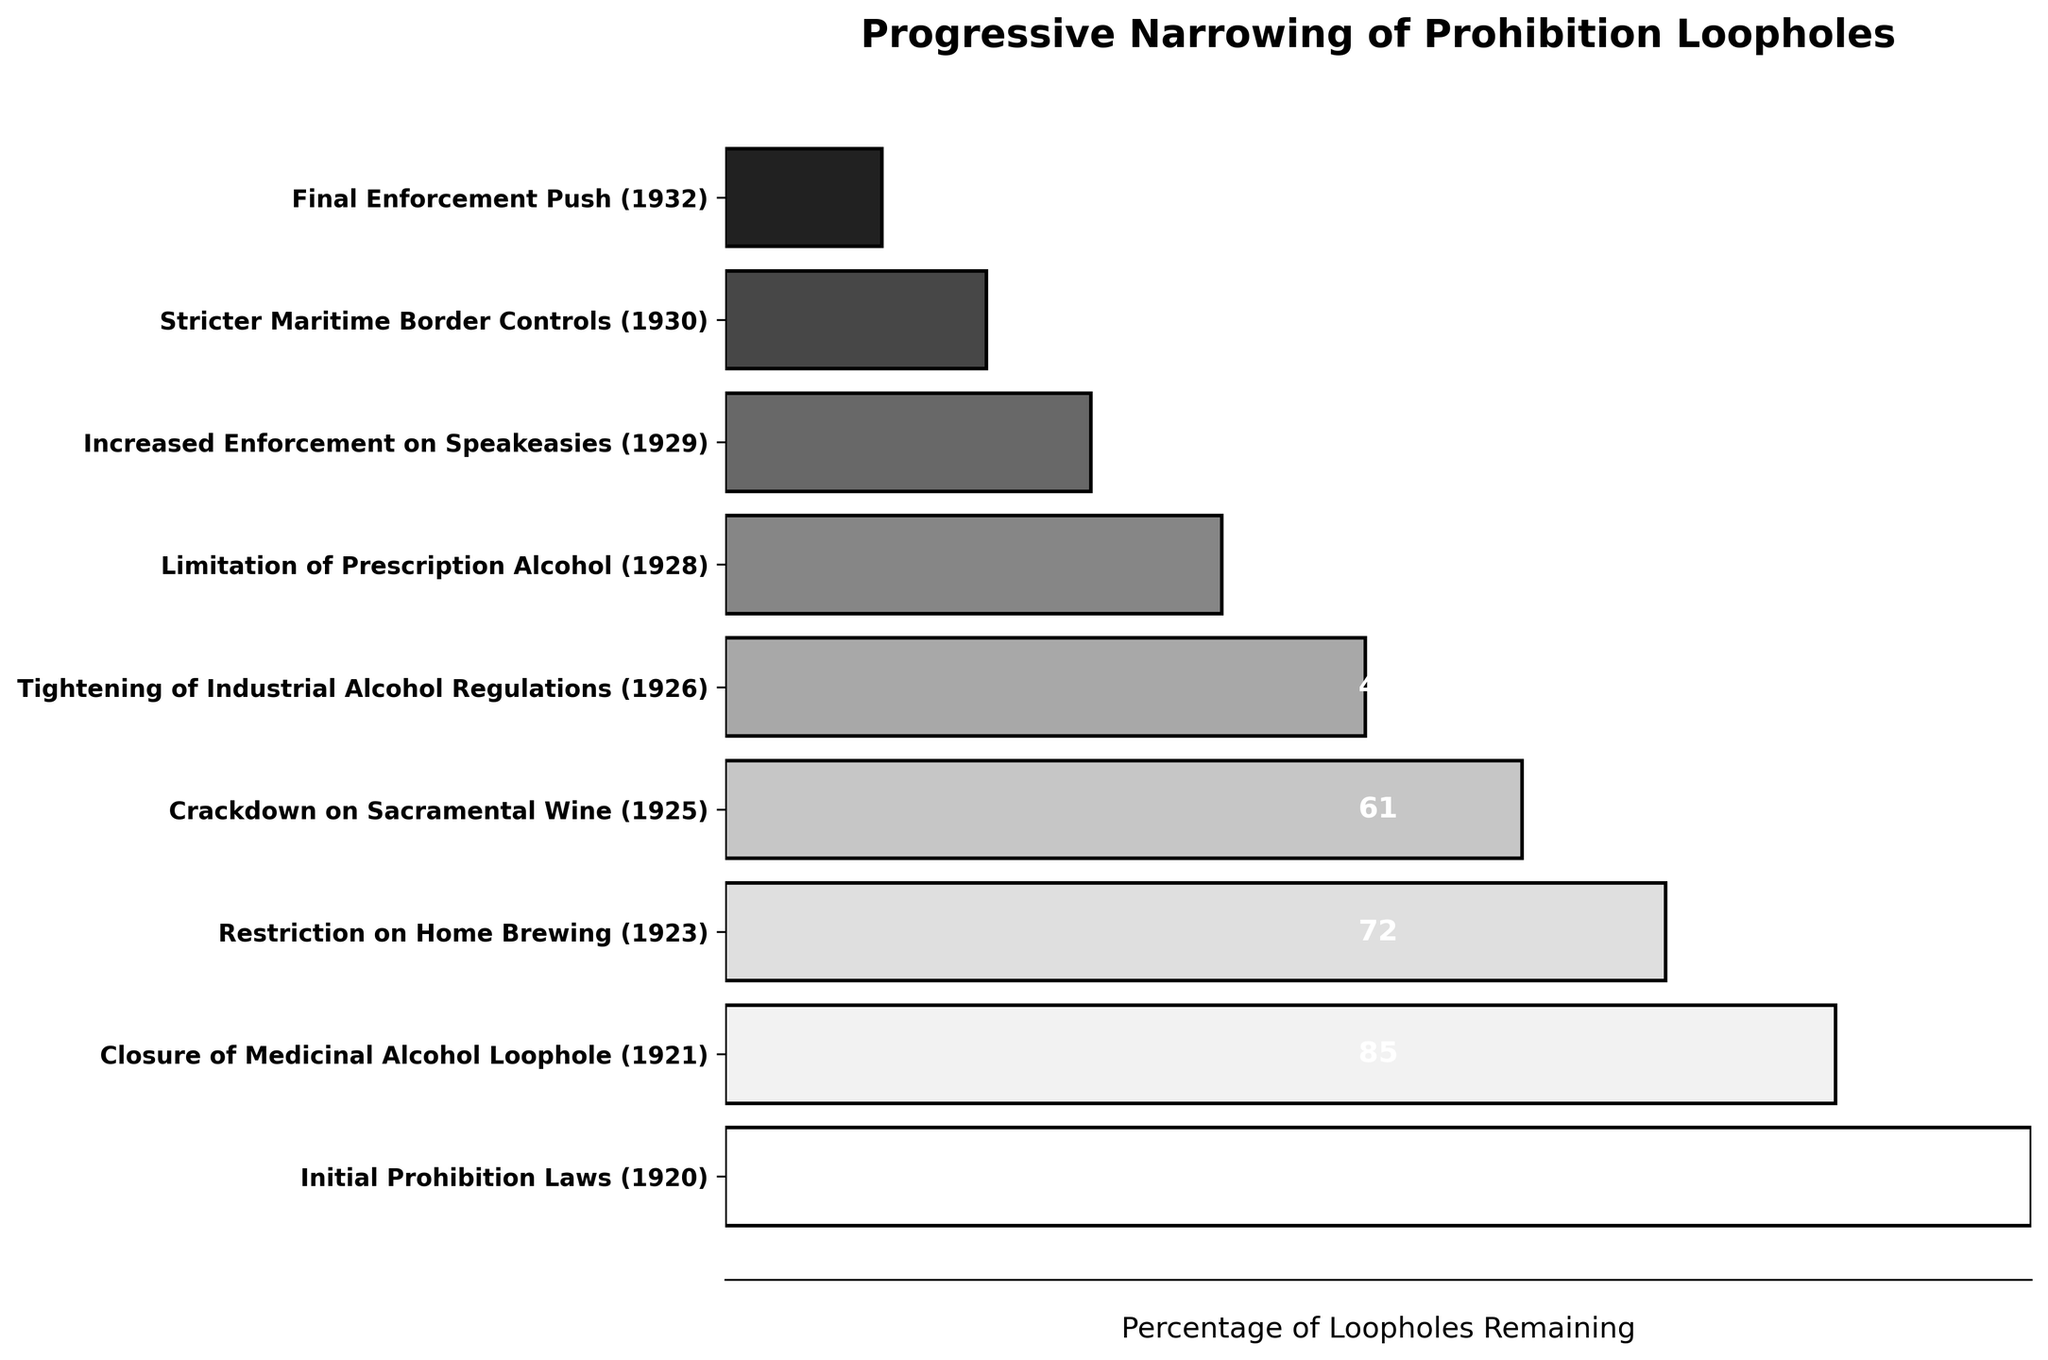What is the title of the figure? The title is displayed at the top of the figure, typically in a larger and bolder font than the rest of the text.
Answer: Progressive Narrowing of Prohibition Loopholes How many stages are illustrated in the figure? Count the number of distinct labels on the y-axis.
Answer: 9 Which stage saw the largest reduction in the number of loopholes from the previous stage? Compare the number of loopholes in each subsequent stage and calculate the difference. The largest reduction is from 72 to 61 between the "Restriction on Home Brewing" and "Crackdown on Sacramental Wine" stages.
Answer: Restriction on Home Brewing to Crackdown on Sacramental Wine What color are the bars in the funnel chart? The bars are shades of gray, as indicated by the grayscale style used in the plot generation.
Answer: Shades of gray How many loopholes were left after the final enforcement push in 1932? Look at the value labeled next to the final stage on the y-axis.
Answer: 12 Which stages combined represent the first half of the funnel chart? The funnel chart is divided into nine stages, so the first half would be the first five stages. These stages are from "Initial Prohibition Laws (1920)" to "Tightening of Industrial Alcohol Regulations (1926)".
Answer: Initial Prohibition Laws to Tightening of Industrial Alcohol Regulations Is the number of loopholes consistently decreasing at each stage? Verify for each stage by comparing it with the previous stage's value to ensure a consistent decline.
Answer: Yes What was the number of loopholes reduced by in the 1929 stage compared to the 1928 stage? Subtract the number of loopholes in 1929 from the number of loopholes in 1928: 38 - 28 = 10.
Answer: 10 Which stage has the widest bar in the funnel chart? The widest bar represents the stage with the maximum number of loopholes, which is the "Initial Prohibition Laws (1920)" stage.
Answer: Initial Prohibition Laws (1920) How many loopholes were remaining after the "Restriction on Home Brewing (1923)" stage? Look at the value labeled next to the "Restriction on Home Brewing (1923)" stage.
Answer: 72 